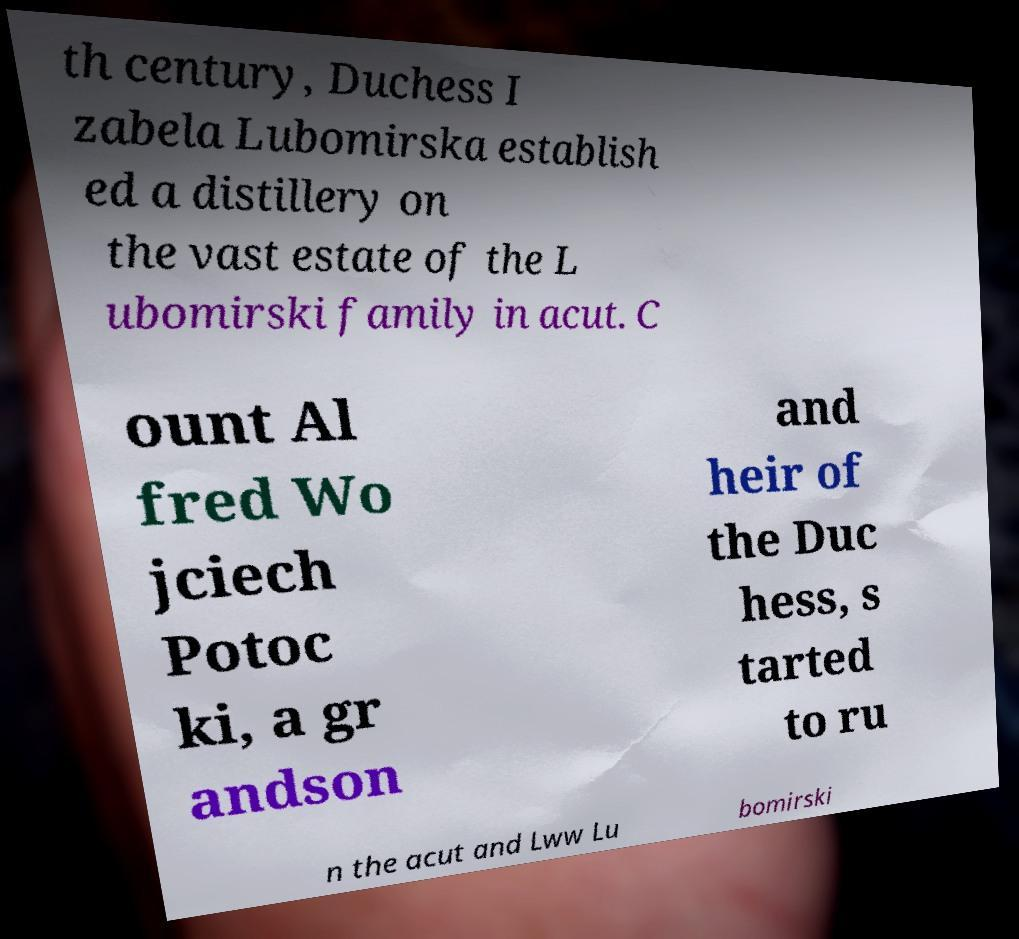For documentation purposes, I need the text within this image transcribed. Could you provide that? th century, Duchess I zabela Lubomirska establish ed a distillery on the vast estate of the L ubomirski family in acut. C ount Al fred Wo jciech Potoc ki, a gr andson and heir of the Duc hess, s tarted to ru n the acut and Lww Lu bomirski 